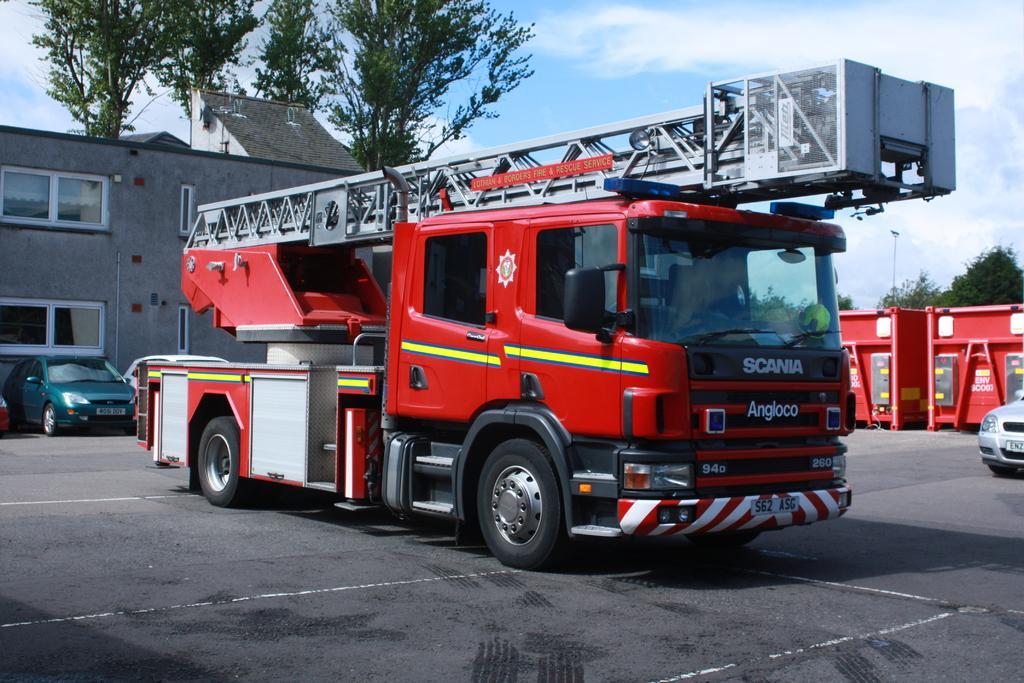Can you describe this image briefly? In this image we can see a fire engine, behind it there are vehicles, houses and a few other objects, in the background there are trees and there are clouds in the sky. 